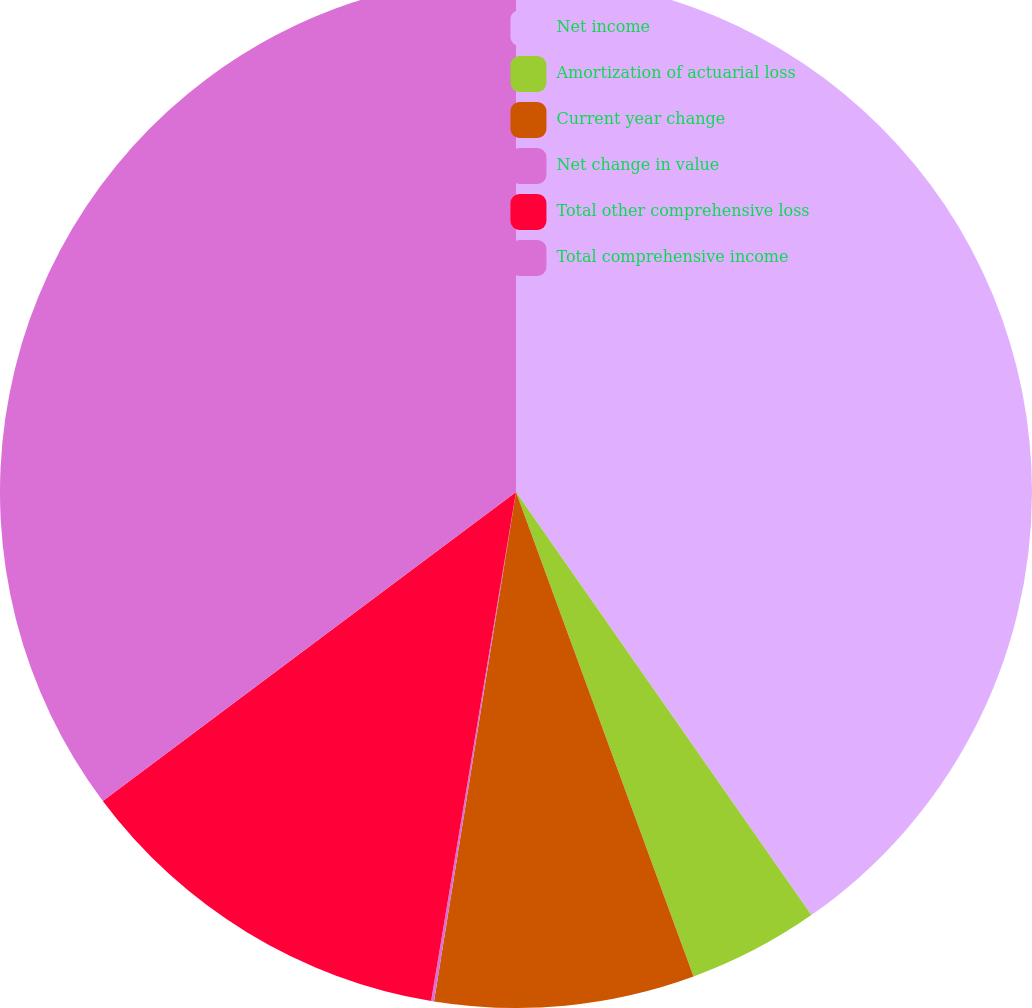Convert chart to OTSL. <chart><loc_0><loc_0><loc_500><loc_500><pie_chart><fcel>Net income<fcel>Amortization of actuarial loss<fcel>Current year change<fcel>Net change in value<fcel>Total other comprehensive loss<fcel>Total comprehensive income<nl><fcel>40.3%<fcel>4.11%<fcel>8.13%<fcel>0.09%<fcel>12.15%<fcel>35.22%<nl></chart> 